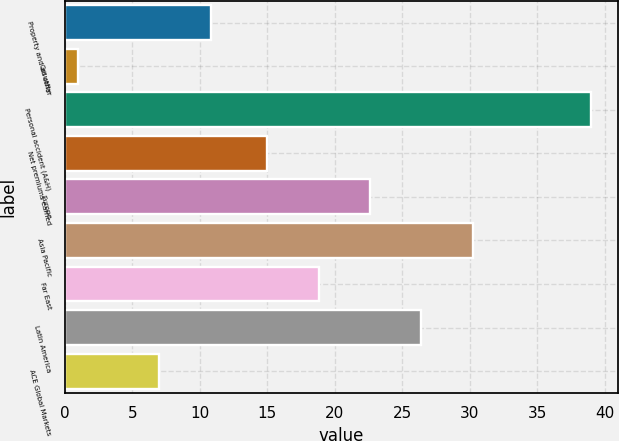Convert chart. <chart><loc_0><loc_0><loc_500><loc_500><bar_chart><fcel>Property and all other<fcel>Casualty<fcel>Personal accident (A&H)<fcel>Net premiums earned<fcel>Europe<fcel>Asia Pacific<fcel>Far East<fcel>Latin America<fcel>ACE Global Markets<nl><fcel>10.8<fcel>1<fcel>39<fcel>15<fcel>22.6<fcel>30.2<fcel>18.8<fcel>26.4<fcel>7<nl></chart> 